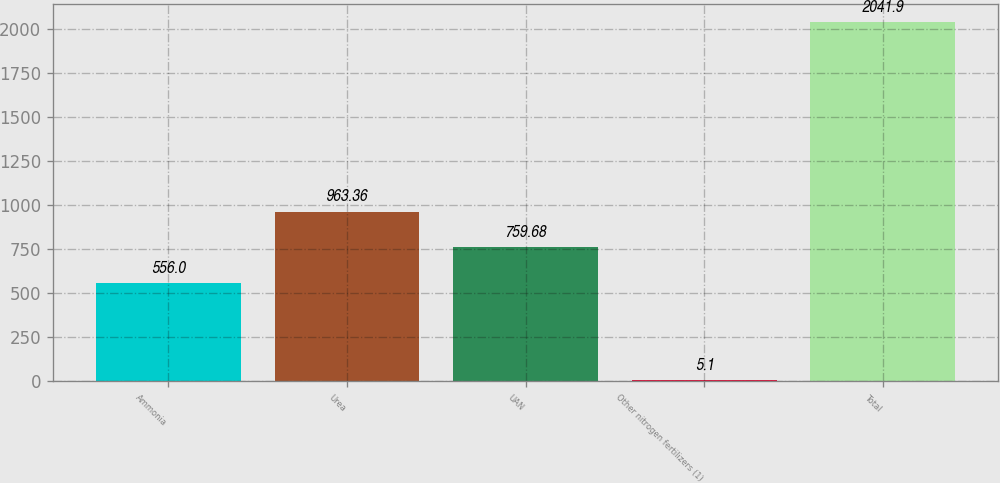<chart> <loc_0><loc_0><loc_500><loc_500><bar_chart><fcel>Ammonia<fcel>Urea<fcel>UAN<fcel>Other nitrogen fertilizers (1)<fcel>Total<nl><fcel>556<fcel>963.36<fcel>759.68<fcel>5.1<fcel>2041.9<nl></chart> 